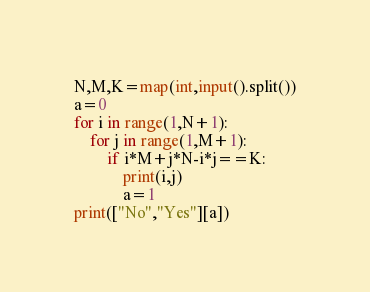<code> <loc_0><loc_0><loc_500><loc_500><_Python_>N,M,K=map(int,input().split())
a=0
for i in range(1,N+1):
    for j in range(1,M+1):
        if i*M+j*N-i*j==K:
            print(i,j)
            a=1
print(["No","Yes"][a])</code> 